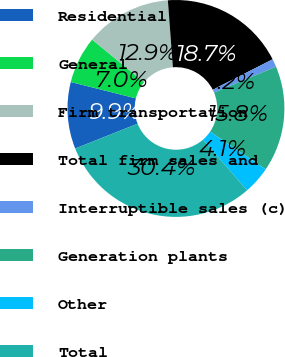<chart> <loc_0><loc_0><loc_500><loc_500><pie_chart><fcel>Residential<fcel>General<fcel>Firm transportation<fcel>Total firm sales and<fcel>Interruptible sales (c)<fcel>Generation plants<fcel>Other<fcel>Total<nl><fcel>9.95%<fcel>7.03%<fcel>12.86%<fcel>18.7%<fcel>1.2%<fcel>15.78%<fcel>4.12%<fcel>30.36%<nl></chart> 